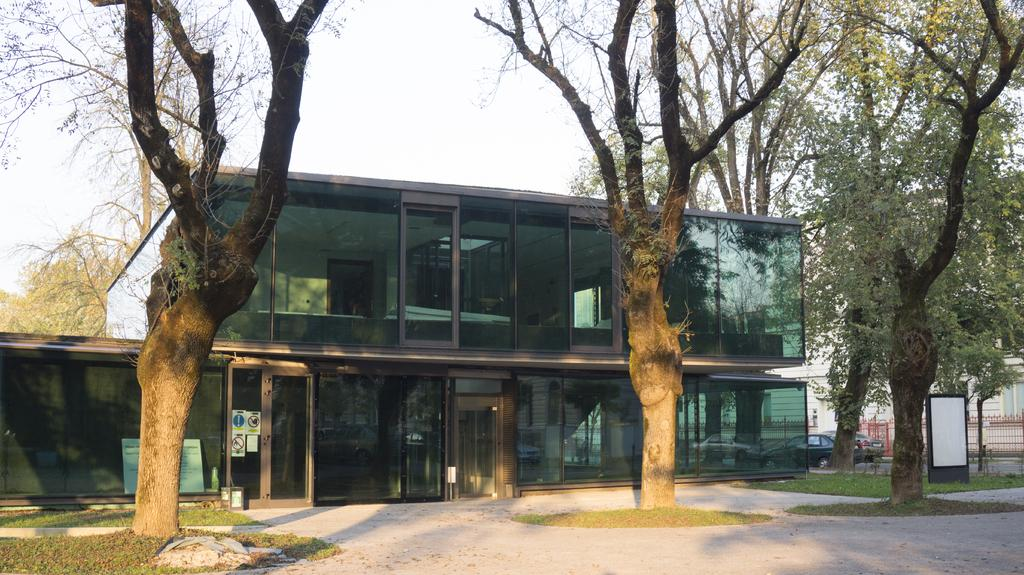What type of vegetation can be seen in the image? There is grass in the image. What type of vehicles are on the road in the image? There are cars on the road in the image. What objects are made of wood in the image? There are boards in the image. What type of printed materials are present in the image? There are posters in the image. How many buildings can be seen in the image? There is at least one building in the image. What objects are used for drinking in the image? There are glasses in the image. What type of natural scenery is visible in the image? There are trees in the image. What part of the natural environment is visible in the background of the image? The sky is visible in the background of the image. What type of army is marching through the grass in the image? There is no army present in the image; it features grass, cars, boards, posters, a building, glasses, trees, and the sky. What color is the skin of the person holding the glasses in the image? There is no person holding glasses in the image; it only shows objects and scenery. 